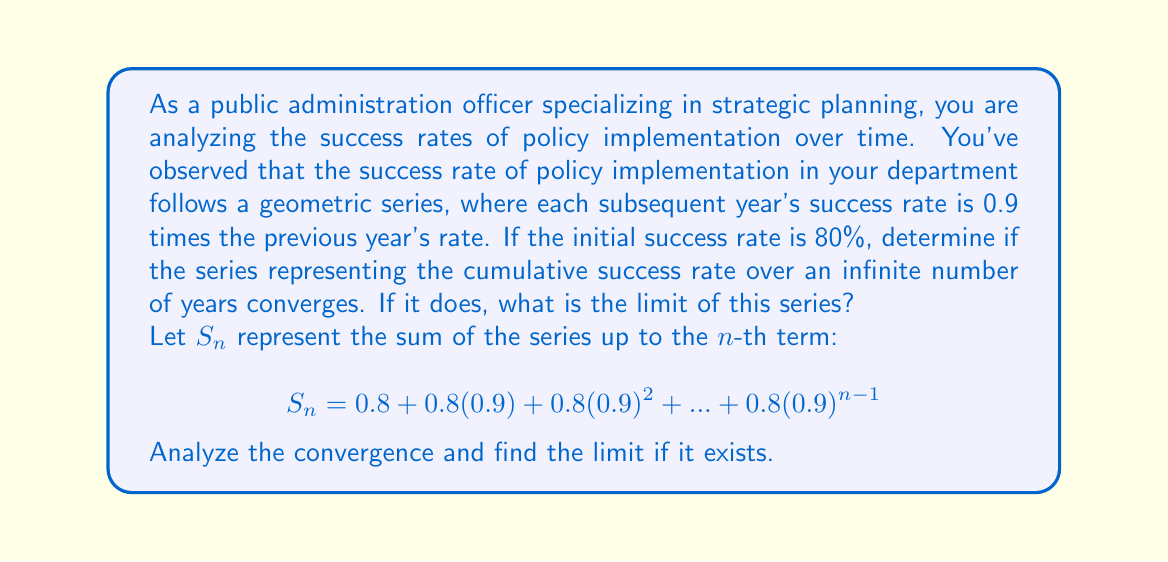Can you solve this math problem? To analyze the convergence and find the limit of this series, we'll follow these steps:

1) First, let's identify the components of this geometric series:
   - First term, $a = 0.8$
   - Common ratio, $r = 0.9$

2) For a geometric series to converge, the absolute value of the common ratio must be less than 1: $|r| < 1$
   In this case, $|0.9| < 1$, so the series converges.

3) For a converging geometric series, the sum to infinity is given by the formula:
   $$S_{\infty} = \frac{a}{1-r}$$

   Where $S_{\infty}$ is the sum to infinity, $a$ is the first term, and $r$ is the common ratio.

4) Substituting our values:
   $$S_{\infty} = \frac{0.8}{1-0.9} = \frac{0.8}{0.1} = 8$$

5) Interpretation: The limit of 8 represents the cumulative success rate over an infinite number of years. This means that if the trend continues indefinitely, the total cumulative success rate would approach 800% or 8 times the initial success rate.

This analysis provides valuable insight for strategic planning, indicating that even with declining yearly success rates, the cumulative impact of the policy over time is significant.
Answer: The series converges, and the limit of the series is 8 or 800%. 